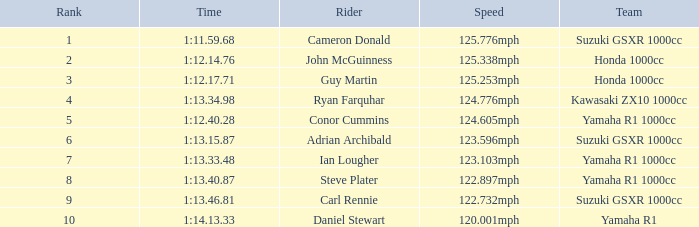What is the rank for the team with a Time of 1:12.40.28? 5.0. 